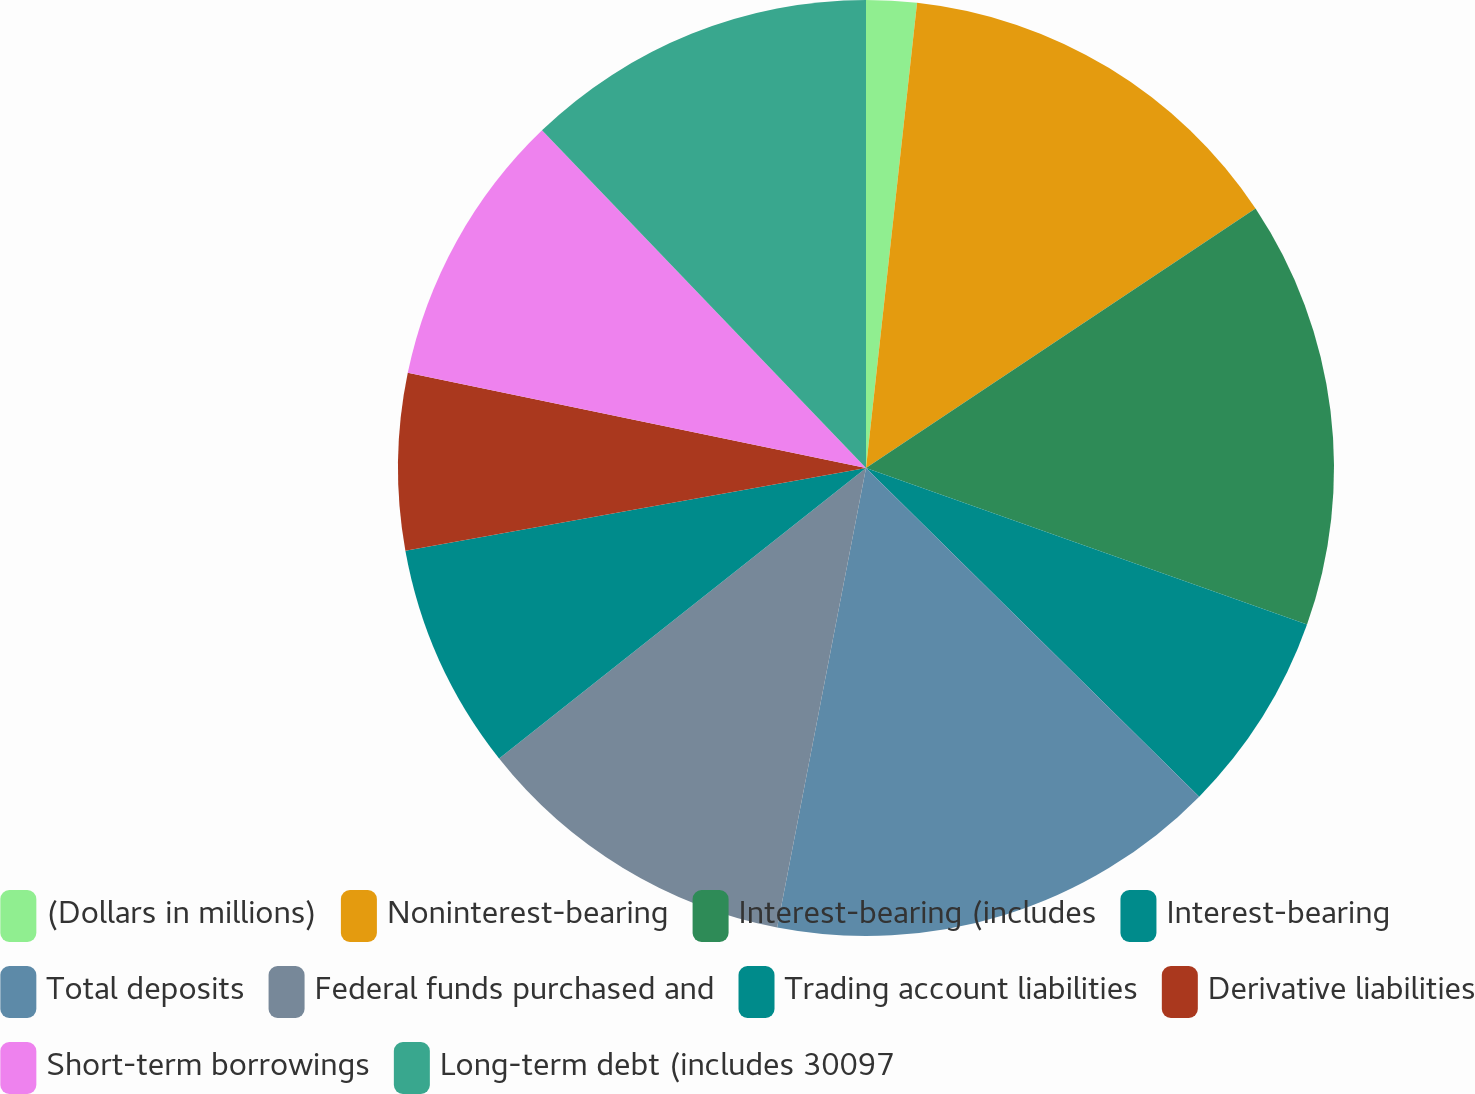<chart> <loc_0><loc_0><loc_500><loc_500><pie_chart><fcel>(Dollars in millions)<fcel>Noninterest-bearing<fcel>Interest-bearing (includes<fcel>Interest-bearing<fcel>Total deposits<fcel>Federal funds purchased and<fcel>Trading account liabilities<fcel>Derivative liabilities<fcel>Short-term borrowings<fcel>Long-term debt (includes 30097<nl><fcel>1.74%<fcel>13.91%<fcel>14.78%<fcel>6.96%<fcel>15.65%<fcel>11.3%<fcel>7.83%<fcel>6.09%<fcel>9.57%<fcel>12.17%<nl></chart> 